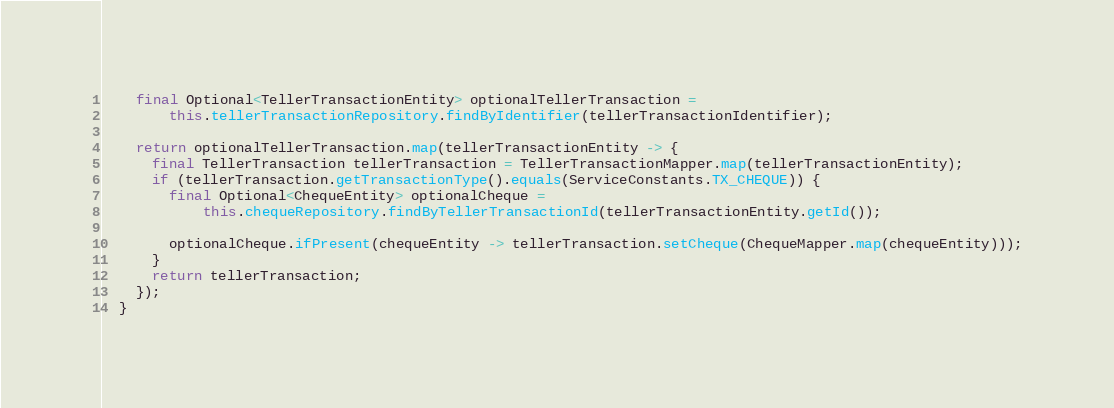Convert code to text. <code><loc_0><loc_0><loc_500><loc_500><_Java_>    final Optional<TellerTransactionEntity> optionalTellerTransaction =
        this.tellerTransactionRepository.findByIdentifier(tellerTransactionIdentifier);

    return optionalTellerTransaction.map(tellerTransactionEntity -> {
      final TellerTransaction tellerTransaction = TellerTransactionMapper.map(tellerTransactionEntity);
      if (tellerTransaction.getTransactionType().equals(ServiceConstants.TX_CHEQUE)) {
        final Optional<ChequeEntity> optionalCheque =
            this.chequeRepository.findByTellerTransactionId(tellerTransactionEntity.getId());

        optionalCheque.ifPresent(chequeEntity -> tellerTransaction.setCheque(ChequeMapper.map(chequeEntity)));
      }
      return tellerTransaction;
    });
  }
</code> 